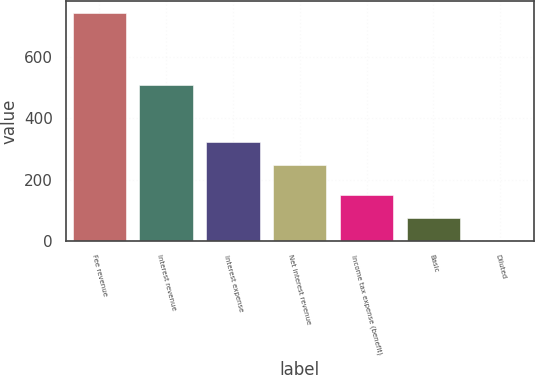Convert chart to OTSL. <chart><loc_0><loc_0><loc_500><loc_500><bar_chart><fcel>Fee revenue<fcel>Interest revenue<fcel>Interest expense<fcel>Net interest revenue<fcel>Income tax expense (benefit)<fcel>Basic<fcel>Diluted<nl><fcel>745<fcel>510<fcel>323.45<fcel>249<fcel>149.44<fcel>74.99<fcel>0.54<nl></chart> 